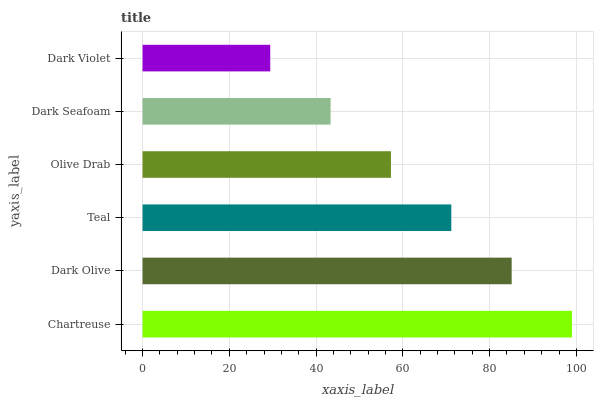Is Dark Violet the minimum?
Answer yes or no. Yes. Is Chartreuse the maximum?
Answer yes or no. Yes. Is Dark Olive the minimum?
Answer yes or no. No. Is Dark Olive the maximum?
Answer yes or no. No. Is Chartreuse greater than Dark Olive?
Answer yes or no. Yes. Is Dark Olive less than Chartreuse?
Answer yes or no. Yes. Is Dark Olive greater than Chartreuse?
Answer yes or no. No. Is Chartreuse less than Dark Olive?
Answer yes or no. No. Is Teal the high median?
Answer yes or no. Yes. Is Olive Drab the low median?
Answer yes or no. Yes. Is Dark Olive the high median?
Answer yes or no. No. Is Dark Seafoam the low median?
Answer yes or no. No. 